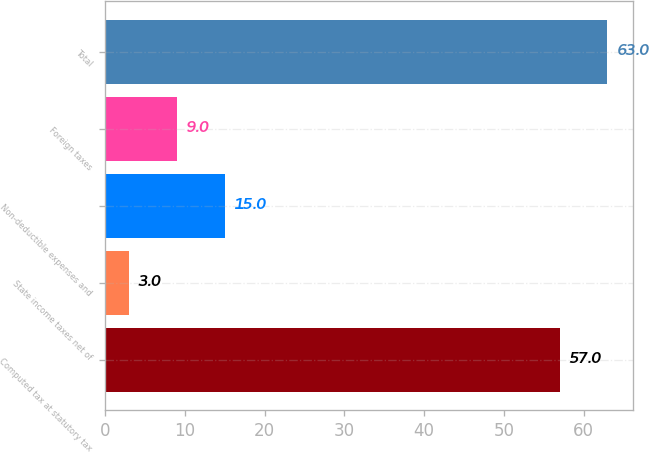<chart> <loc_0><loc_0><loc_500><loc_500><bar_chart><fcel>Computed tax at statutory tax<fcel>State income taxes net of<fcel>Non-deductible expenses and<fcel>Foreign taxes<fcel>Total<nl><fcel>57<fcel>3<fcel>15<fcel>9<fcel>63<nl></chart> 